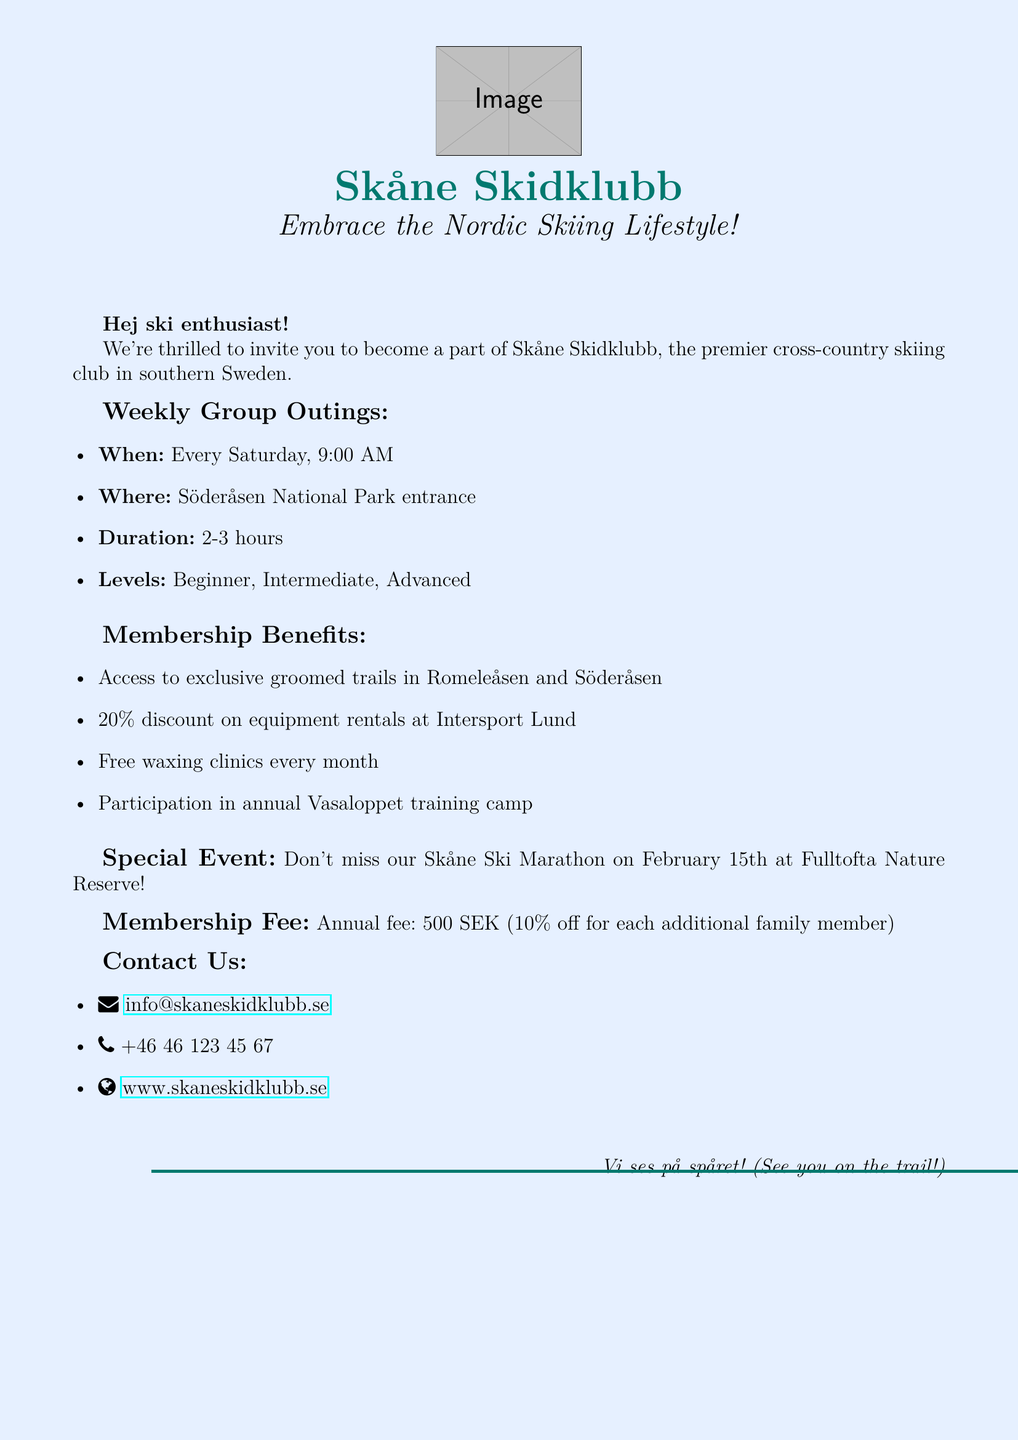What day of the week are the group outings? The document states that group outings occur every Saturday.
Answer: Saturday What is the duration of the weekly outings? The document mentions the outings last 2-3 hours.
Answer: 2-3 hours What is the annual membership fee? The document specifies the annual fee is 500 SEK.
Answer: 500 SEK What special event is mentioned in the document? The document highlights the Skåne Ski Marathon as a special event.
Answer: Skåne Ski Marathon What is the discount rate on equipment rentals? The document states there is a 20% discount on equipment rentals at Intersport Lund.
Answer: 20% How often are the waxing clinics held? The document indicates that the waxing clinics are free and held every month.
Answer: Every month Where is the meeting point for the group outings? The document specifies that the meeting point is the Söderåsen National Park entrance.
Answer: Söderåsen National Park entrance What types of skiing skill levels are offered during the outings? The document lists beginner, intermediate, and advanced as available skill levels.
Answer: Beginner, Intermediate, Advanced Is there a family discount for the membership fee? The document states that there is a 10% discount for each additional family member.
Answer: Yes, 10% discount 